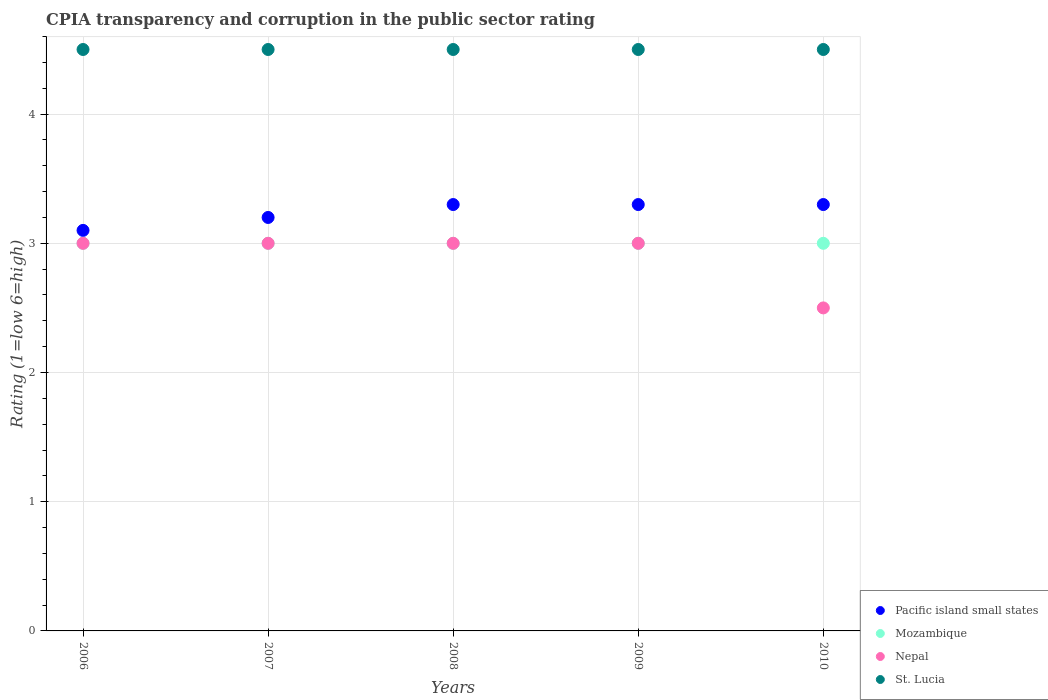Is the number of dotlines equal to the number of legend labels?
Ensure brevity in your answer.  Yes. What is the CPIA rating in Nepal in 2007?
Give a very brief answer. 3. Across all years, what is the minimum CPIA rating in Mozambique?
Provide a short and direct response. 3. In which year was the CPIA rating in Nepal maximum?
Give a very brief answer. 2006. What is the difference between the CPIA rating in St. Lucia in 2008 and that in 2010?
Make the answer very short. 0. What is the difference between the CPIA rating in Mozambique in 2010 and the CPIA rating in St. Lucia in 2009?
Your response must be concise. -1.5. In the year 2010, what is the difference between the CPIA rating in Nepal and CPIA rating in Pacific island small states?
Make the answer very short. -0.8. In how many years, is the CPIA rating in Nepal greater than 4.2?
Make the answer very short. 0. Is the CPIA rating in St. Lucia in 2008 less than that in 2009?
Give a very brief answer. No. Is the difference between the CPIA rating in Nepal in 2008 and 2010 greater than the difference between the CPIA rating in Pacific island small states in 2008 and 2010?
Keep it short and to the point. Yes. In how many years, is the CPIA rating in Nepal greater than the average CPIA rating in Nepal taken over all years?
Offer a terse response. 4. Is it the case that in every year, the sum of the CPIA rating in Mozambique and CPIA rating in Nepal  is greater than the sum of CPIA rating in St. Lucia and CPIA rating in Pacific island small states?
Your answer should be compact. No. Is it the case that in every year, the sum of the CPIA rating in Mozambique and CPIA rating in Pacific island small states  is greater than the CPIA rating in Nepal?
Offer a very short reply. Yes. How many dotlines are there?
Offer a terse response. 4. How many years are there in the graph?
Make the answer very short. 5. What is the difference between two consecutive major ticks on the Y-axis?
Offer a terse response. 1. Are the values on the major ticks of Y-axis written in scientific E-notation?
Make the answer very short. No. Does the graph contain any zero values?
Keep it short and to the point. No. Does the graph contain grids?
Make the answer very short. Yes. How many legend labels are there?
Provide a succinct answer. 4. How are the legend labels stacked?
Ensure brevity in your answer.  Vertical. What is the title of the graph?
Offer a very short reply. CPIA transparency and corruption in the public sector rating. Does "Canada" appear as one of the legend labels in the graph?
Your answer should be compact. No. What is the label or title of the Y-axis?
Your response must be concise. Rating (1=low 6=high). What is the Rating (1=low 6=high) in Pacific island small states in 2007?
Provide a succinct answer. 3.2. What is the Rating (1=low 6=high) in Nepal in 2007?
Ensure brevity in your answer.  3. What is the Rating (1=low 6=high) of St. Lucia in 2007?
Give a very brief answer. 4.5. What is the Rating (1=low 6=high) in Mozambique in 2008?
Make the answer very short. 3. What is the Rating (1=low 6=high) in Pacific island small states in 2009?
Your answer should be compact. 3.3. What is the Rating (1=low 6=high) in Mozambique in 2009?
Provide a short and direct response. 3. What is the Rating (1=low 6=high) of Nepal in 2009?
Ensure brevity in your answer.  3. What is the Rating (1=low 6=high) in St. Lucia in 2010?
Make the answer very short. 4.5. Across all years, what is the maximum Rating (1=low 6=high) of Mozambique?
Provide a short and direct response. 3. Across all years, what is the maximum Rating (1=low 6=high) of St. Lucia?
Give a very brief answer. 4.5. Across all years, what is the minimum Rating (1=low 6=high) of St. Lucia?
Offer a terse response. 4.5. What is the total Rating (1=low 6=high) in St. Lucia in the graph?
Your answer should be very brief. 22.5. What is the difference between the Rating (1=low 6=high) in Nepal in 2006 and that in 2007?
Give a very brief answer. 0. What is the difference between the Rating (1=low 6=high) of Nepal in 2006 and that in 2008?
Give a very brief answer. 0. What is the difference between the Rating (1=low 6=high) in St. Lucia in 2006 and that in 2008?
Your response must be concise. 0. What is the difference between the Rating (1=low 6=high) of Nepal in 2006 and that in 2009?
Keep it short and to the point. 0. What is the difference between the Rating (1=low 6=high) of Mozambique in 2006 and that in 2010?
Keep it short and to the point. 0. What is the difference between the Rating (1=low 6=high) in Nepal in 2006 and that in 2010?
Provide a succinct answer. 0.5. What is the difference between the Rating (1=low 6=high) of St. Lucia in 2006 and that in 2010?
Offer a terse response. 0. What is the difference between the Rating (1=low 6=high) in Mozambique in 2007 and that in 2008?
Your response must be concise. 0. What is the difference between the Rating (1=low 6=high) in Nepal in 2007 and that in 2008?
Ensure brevity in your answer.  0. What is the difference between the Rating (1=low 6=high) in St. Lucia in 2007 and that in 2008?
Your answer should be very brief. 0. What is the difference between the Rating (1=low 6=high) of Nepal in 2007 and that in 2009?
Keep it short and to the point. 0. What is the difference between the Rating (1=low 6=high) in St. Lucia in 2007 and that in 2009?
Keep it short and to the point. 0. What is the difference between the Rating (1=low 6=high) in Pacific island small states in 2007 and that in 2010?
Provide a succinct answer. -0.1. What is the difference between the Rating (1=low 6=high) in Nepal in 2008 and that in 2009?
Ensure brevity in your answer.  0. What is the difference between the Rating (1=low 6=high) in Pacific island small states in 2008 and that in 2010?
Your response must be concise. 0. What is the difference between the Rating (1=low 6=high) in Mozambique in 2008 and that in 2010?
Keep it short and to the point. 0. What is the difference between the Rating (1=low 6=high) of Nepal in 2008 and that in 2010?
Offer a terse response. 0.5. What is the difference between the Rating (1=low 6=high) of St. Lucia in 2008 and that in 2010?
Keep it short and to the point. 0. What is the difference between the Rating (1=low 6=high) of Pacific island small states in 2006 and the Rating (1=low 6=high) of Mozambique in 2007?
Offer a terse response. 0.1. What is the difference between the Rating (1=low 6=high) of Mozambique in 2006 and the Rating (1=low 6=high) of Nepal in 2007?
Give a very brief answer. 0. What is the difference between the Rating (1=low 6=high) in Pacific island small states in 2006 and the Rating (1=low 6=high) in Mozambique in 2009?
Your answer should be compact. 0.1. What is the difference between the Rating (1=low 6=high) in Pacific island small states in 2006 and the Rating (1=low 6=high) in Nepal in 2009?
Make the answer very short. 0.1. What is the difference between the Rating (1=low 6=high) in Mozambique in 2006 and the Rating (1=low 6=high) in Nepal in 2009?
Offer a terse response. 0. What is the difference between the Rating (1=low 6=high) in Mozambique in 2006 and the Rating (1=low 6=high) in St. Lucia in 2009?
Provide a succinct answer. -1.5. What is the difference between the Rating (1=low 6=high) of Nepal in 2006 and the Rating (1=low 6=high) of St. Lucia in 2009?
Your response must be concise. -1.5. What is the difference between the Rating (1=low 6=high) in Pacific island small states in 2006 and the Rating (1=low 6=high) in Mozambique in 2010?
Your response must be concise. 0.1. What is the difference between the Rating (1=low 6=high) of Pacific island small states in 2006 and the Rating (1=low 6=high) of Nepal in 2010?
Your answer should be compact. 0.6. What is the difference between the Rating (1=low 6=high) in Pacific island small states in 2006 and the Rating (1=low 6=high) in St. Lucia in 2010?
Ensure brevity in your answer.  -1.4. What is the difference between the Rating (1=low 6=high) in Mozambique in 2006 and the Rating (1=low 6=high) in Nepal in 2010?
Offer a very short reply. 0.5. What is the difference between the Rating (1=low 6=high) of Nepal in 2006 and the Rating (1=low 6=high) of St. Lucia in 2010?
Ensure brevity in your answer.  -1.5. What is the difference between the Rating (1=low 6=high) in Pacific island small states in 2007 and the Rating (1=low 6=high) in Nepal in 2008?
Keep it short and to the point. 0.2. What is the difference between the Rating (1=low 6=high) of Nepal in 2007 and the Rating (1=low 6=high) of St. Lucia in 2008?
Your response must be concise. -1.5. What is the difference between the Rating (1=low 6=high) in Pacific island small states in 2007 and the Rating (1=low 6=high) in Mozambique in 2009?
Your response must be concise. 0.2. What is the difference between the Rating (1=low 6=high) of Mozambique in 2007 and the Rating (1=low 6=high) of Nepal in 2009?
Your answer should be very brief. 0. What is the difference between the Rating (1=low 6=high) of Mozambique in 2007 and the Rating (1=low 6=high) of St. Lucia in 2009?
Your response must be concise. -1.5. What is the difference between the Rating (1=low 6=high) in Mozambique in 2007 and the Rating (1=low 6=high) in St. Lucia in 2010?
Provide a succinct answer. -1.5. What is the difference between the Rating (1=low 6=high) in Nepal in 2007 and the Rating (1=low 6=high) in St. Lucia in 2010?
Offer a very short reply. -1.5. What is the difference between the Rating (1=low 6=high) of Pacific island small states in 2008 and the Rating (1=low 6=high) of Mozambique in 2009?
Make the answer very short. 0.3. What is the difference between the Rating (1=low 6=high) of Pacific island small states in 2008 and the Rating (1=low 6=high) of Nepal in 2009?
Provide a short and direct response. 0.3. What is the difference between the Rating (1=low 6=high) of Mozambique in 2008 and the Rating (1=low 6=high) of St. Lucia in 2009?
Give a very brief answer. -1.5. What is the difference between the Rating (1=low 6=high) of Nepal in 2008 and the Rating (1=low 6=high) of St. Lucia in 2010?
Keep it short and to the point. -1.5. What is the average Rating (1=low 6=high) of Pacific island small states per year?
Provide a succinct answer. 3.24. In the year 2006, what is the difference between the Rating (1=low 6=high) of Pacific island small states and Rating (1=low 6=high) of St. Lucia?
Provide a short and direct response. -1.4. In the year 2006, what is the difference between the Rating (1=low 6=high) of Mozambique and Rating (1=low 6=high) of Nepal?
Offer a very short reply. 0. In the year 2006, what is the difference between the Rating (1=low 6=high) in Nepal and Rating (1=low 6=high) in St. Lucia?
Make the answer very short. -1.5. In the year 2007, what is the difference between the Rating (1=low 6=high) in Pacific island small states and Rating (1=low 6=high) in Nepal?
Your response must be concise. 0.2. In the year 2007, what is the difference between the Rating (1=low 6=high) in Mozambique and Rating (1=low 6=high) in Nepal?
Ensure brevity in your answer.  0. In the year 2007, what is the difference between the Rating (1=low 6=high) of Mozambique and Rating (1=low 6=high) of St. Lucia?
Your answer should be very brief. -1.5. In the year 2007, what is the difference between the Rating (1=low 6=high) in Nepal and Rating (1=low 6=high) in St. Lucia?
Ensure brevity in your answer.  -1.5. In the year 2008, what is the difference between the Rating (1=low 6=high) of Pacific island small states and Rating (1=low 6=high) of St. Lucia?
Offer a very short reply. -1.2. In the year 2009, what is the difference between the Rating (1=low 6=high) in Pacific island small states and Rating (1=low 6=high) in Nepal?
Keep it short and to the point. 0.3. In the year 2009, what is the difference between the Rating (1=low 6=high) of Pacific island small states and Rating (1=low 6=high) of St. Lucia?
Offer a terse response. -1.2. In the year 2009, what is the difference between the Rating (1=low 6=high) in Mozambique and Rating (1=low 6=high) in St. Lucia?
Keep it short and to the point. -1.5. In the year 2009, what is the difference between the Rating (1=low 6=high) of Nepal and Rating (1=low 6=high) of St. Lucia?
Ensure brevity in your answer.  -1.5. In the year 2010, what is the difference between the Rating (1=low 6=high) of Pacific island small states and Rating (1=low 6=high) of Nepal?
Give a very brief answer. 0.8. In the year 2010, what is the difference between the Rating (1=low 6=high) in Pacific island small states and Rating (1=low 6=high) in St. Lucia?
Make the answer very short. -1.2. In the year 2010, what is the difference between the Rating (1=low 6=high) of Mozambique and Rating (1=low 6=high) of Nepal?
Make the answer very short. 0.5. In the year 2010, what is the difference between the Rating (1=low 6=high) in Mozambique and Rating (1=low 6=high) in St. Lucia?
Keep it short and to the point. -1.5. In the year 2010, what is the difference between the Rating (1=low 6=high) in Nepal and Rating (1=low 6=high) in St. Lucia?
Offer a terse response. -2. What is the ratio of the Rating (1=low 6=high) of Pacific island small states in 2006 to that in 2007?
Your answer should be compact. 0.97. What is the ratio of the Rating (1=low 6=high) of Mozambique in 2006 to that in 2007?
Your answer should be very brief. 1. What is the ratio of the Rating (1=low 6=high) in Nepal in 2006 to that in 2007?
Your response must be concise. 1. What is the ratio of the Rating (1=low 6=high) of St. Lucia in 2006 to that in 2007?
Provide a succinct answer. 1. What is the ratio of the Rating (1=low 6=high) of Pacific island small states in 2006 to that in 2008?
Offer a very short reply. 0.94. What is the ratio of the Rating (1=low 6=high) of Mozambique in 2006 to that in 2008?
Provide a succinct answer. 1. What is the ratio of the Rating (1=low 6=high) of Pacific island small states in 2006 to that in 2009?
Your answer should be compact. 0.94. What is the ratio of the Rating (1=low 6=high) in Nepal in 2006 to that in 2009?
Your answer should be very brief. 1. What is the ratio of the Rating (1=low 6=high) of Pacific island small states in 2006 to that in 2010?
Provide a short and direct response. 0.94. What is the ratio of the Rating (1=low 6=high) of Mozambique in 2006 to that in 2010?
Provide a short and direct response. 1. What is the ratio of the Rating (1=low 6=high) in St. Lucia in 2006 to that in 2010?
Ensure brevity in your answer.  1. What is the ratio of the Rating (1=low 6=high) of Pacific island small states in 2007 to that in 2008?
Your answer should be very brief. 0.97. What is the ratio of the Rating (1=low 6=high) of St. Lucia in 2007 to that in 2008?
Your answer should be very brief. 1. What is the ratio of the Rating (1=low 6=high) in Pacific island small states in 2007 to that in 2009?
Your answer should be compact. 0.97. What is the ratio of the Rating (1=low 6=high) in Mozambique in 2007 to that in 2009?
Offer a very short reply. 1. What is the ratio of the Rating (1=low 6=high) in St. Lucia in 2007 to that in 2009?
Your response must be concise. 1. What is the ratio of the Rating (1=low 6=high) of Pacific island small states in 2007 to that in 2010?
Offer a terse response. 0.97. What is the ratio of the Rating (1=low 6=high) of Mozambique in 2007 to that in 2010?
Your answer should be compact. 1. What is the ratio of the Rating (1=low 6=high) of Pacific island small states in 2008 to that in 2009?
Your answer should be compact. 1. What is the ratio of the Rating (1=low 6=high) of St. Lucia in 2008 to that in 2009?
Your response must be concise. 1. What is the ratio of the Rating (1=low 6=high) in Pacific island small states in 2008 to that in 2010?
Your response must be concise. 1. What is the ratio of the Rating (1=low 6=high) in Mozambique in 2009 to that in 2010?
Your response must be concise. 1. What is the difference between the highest and the lowest Rating (1=low 6=high) in Pacific island small states?
Offer a terse response. 0.2. What is the difference between the highest and the lowest Rating (1=low 6=high) of St. Lucia?
Your answer should be very brief. 0. 